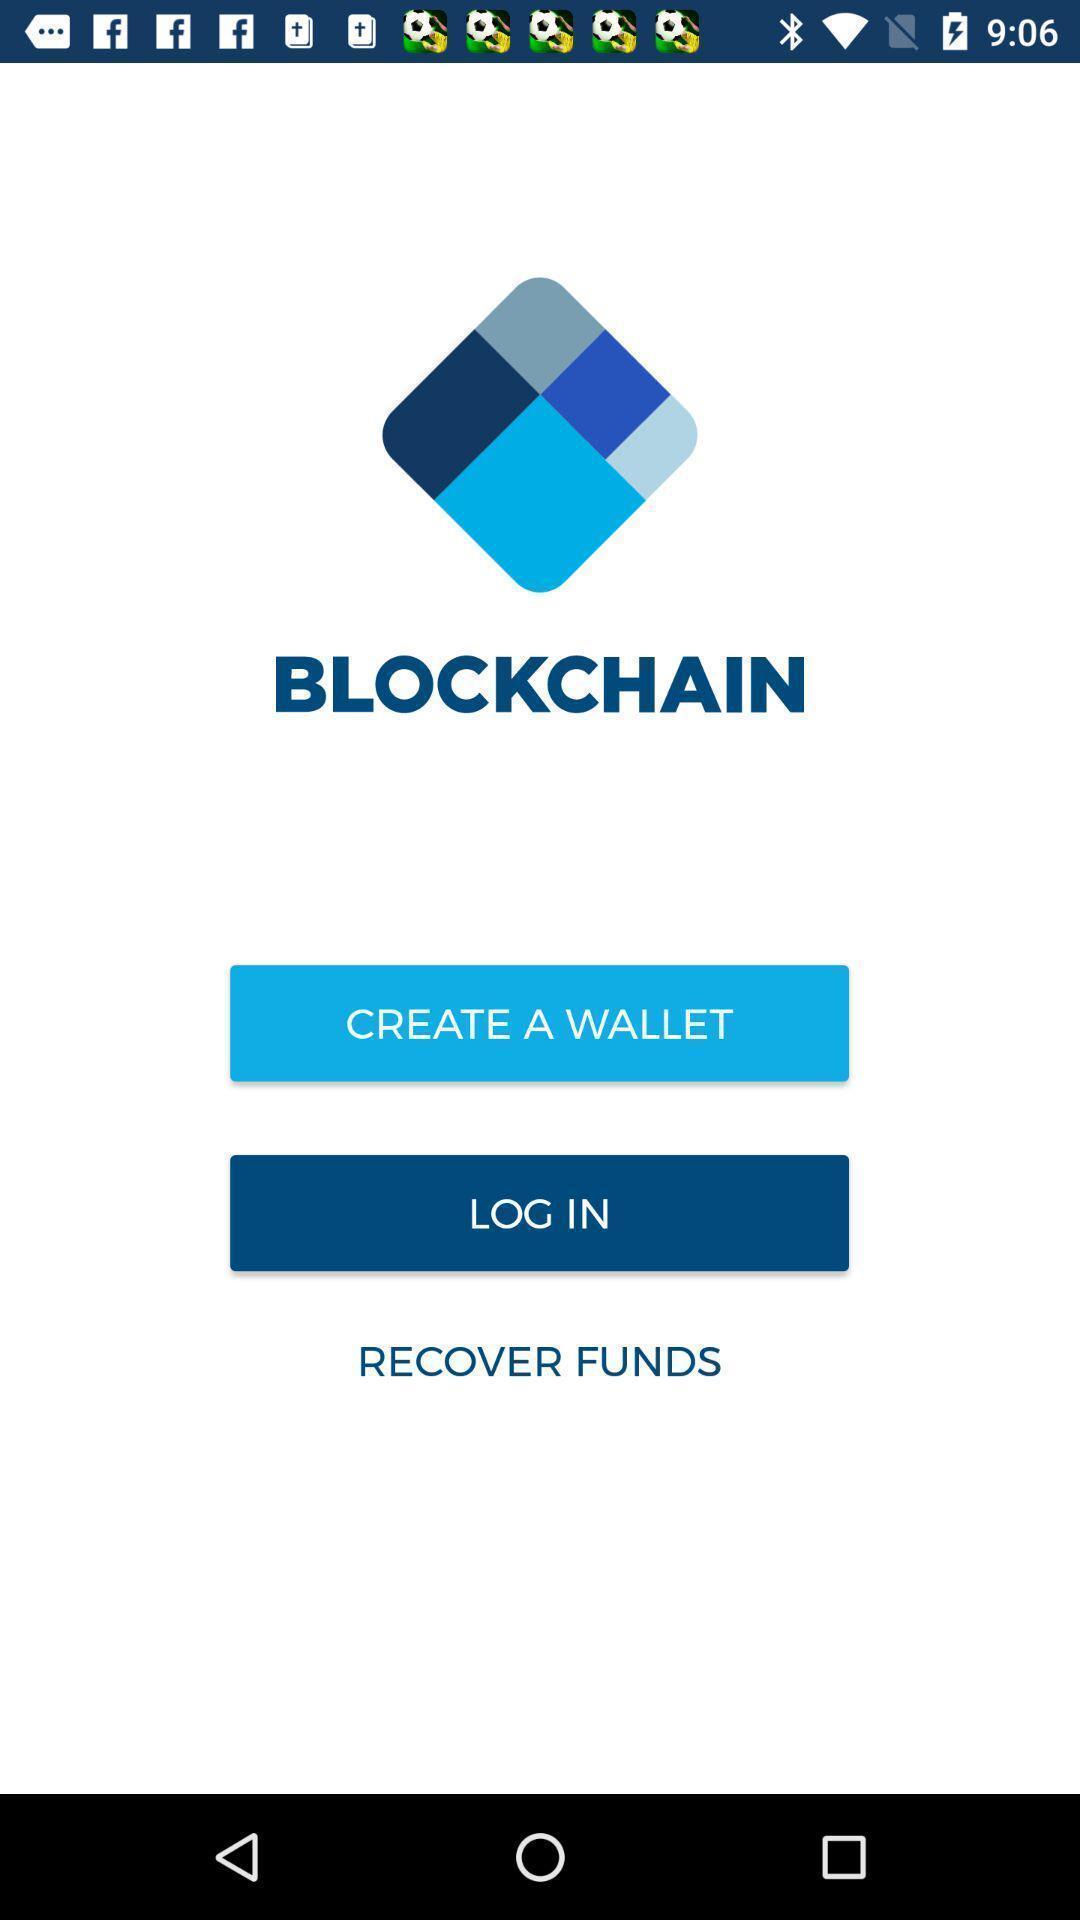Describe the content in this image. Starting page of a business application. 